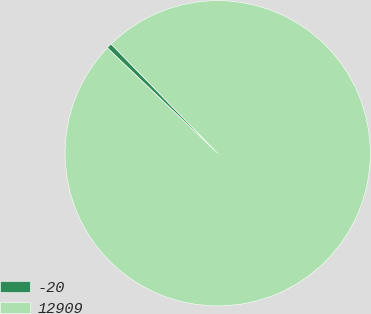Convert chart to OTSL. <chart><loc_0><loc_0><loc_500><loc_500><pie_chart><fcel>-20<fcel>12909<nl><fcel>0.56%<fcel>99.44%<nl></chart> 